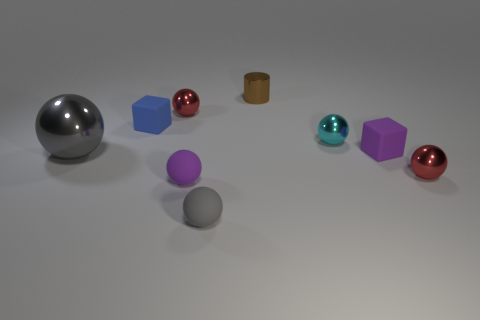Subtract 3 spheres. How many spheres are left? 3 Subtract all purple spheres. How many spheres are left? 5 Subtract all tiny gray rubber spheres. How many spheres are left? 5 Subtract all yellow balls. Subtract all gray cylinders. How many balls are left? 6 Add 1 brown metallic cylinders. How many objects exist? 10 Subtract all cylinders. How many objects are left? 8 Subtract 1 cyan spheres. How many objects are left? 8 Subtract all gray matte spheres. Subtract all cubes. How many objects are left? 6 Add 4 shiny balls. How many shiny balls are left? 8 Add 6 shiny spheres. How many shiny spheres exist? 10 